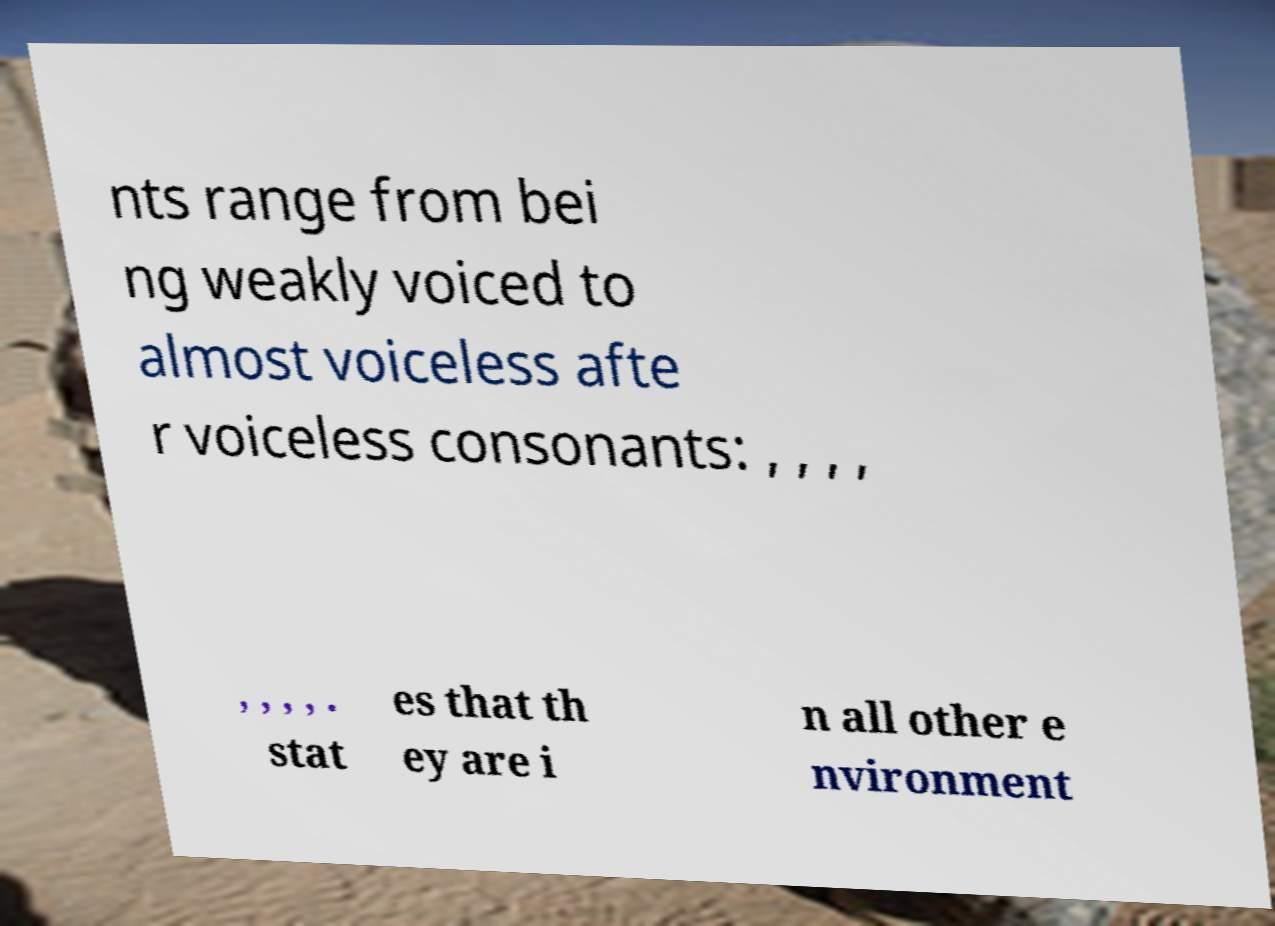Can you accurately transcribe the text from the provided image for me? nts range from bei ng weakly voiced to almost voiceless afte r voiceless consonants: , , , , , , , , . stat es that th ey are i n all other e nvironment 